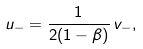<formula> <loc_0><loc_0><loc_500><loc_500>u _ { - } = \frac { 1 } { 2 ( 1 - \beta ) } \, v _ { - } ,</formula> 